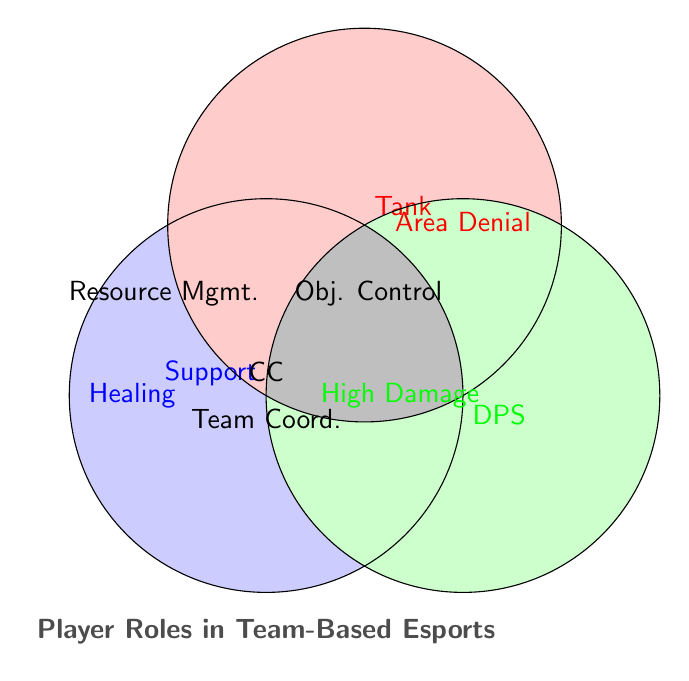Which role has 'Healing'? To find which role has 'Healing', identify the blue section labeled 'Healing' that overlaps with 'Support' and 'Tank' but not 'DPS'.
Answer: Support Which role is responsible for 'High Damage Output'? Check for the green section labeled 'High Damage' which aligns with the DPS circle only.
Answer: DPS How many roles have 'Crowd Control'? 'Crowd Control' lies at the intersection of all three circles. Thus, it involves all three roles: Support, Tank, and DPS.
Answer: Three Which roles are involved in 'Area Denial'? 'Area Denial' is located in the red circle overlapping with the Tank and DPS sections only, but not Support.
Answer: Tank and DPS What is the common responsibility among all three roles? Identify the overlapping area where all three circles intersect. It is labeled as 'Crowd Control', 'Team Coordination', 'Ultimate Ability Timing', 'Positioning', and 'Map Awareness'.
Answer: Crowd Control, Team Coordination, Ultimate Ability Timing, Positioning, Map Awareness Which role handles 'Resource Management', but not 'Objective Control'? 'Resource Management' is found in the blue circle overlapping with 'Support' and DPS but not Tank. However, 'Objective Control' is excluded from Support and included for DPS. Support is the only role that fits both conditions.
Answer: Support What is a shared responsibility between Support and Tank, excluding DPS? Look for the section that is between the blue and red circles not overlapping with the green circle. This is labeled 'Healing' and 'Resource Management'.
Answer: Healing, Resource Management Which roles are involved in both 'Map Awareness' and 'Team Coordination'? Both responsibilities are found in the intersection of all three roles: Support, Tank, and DPS.
Answer: Support, Tank, DPS Who handles 'Objective Control' and how many unique roles are involved? 'Objective Control' is located within the intersections of Tank and DPS, excluding Support. The count of unique roles includes Tank and DPS, totaling two unique roles.
Answer: Two (Tank, DPS) 